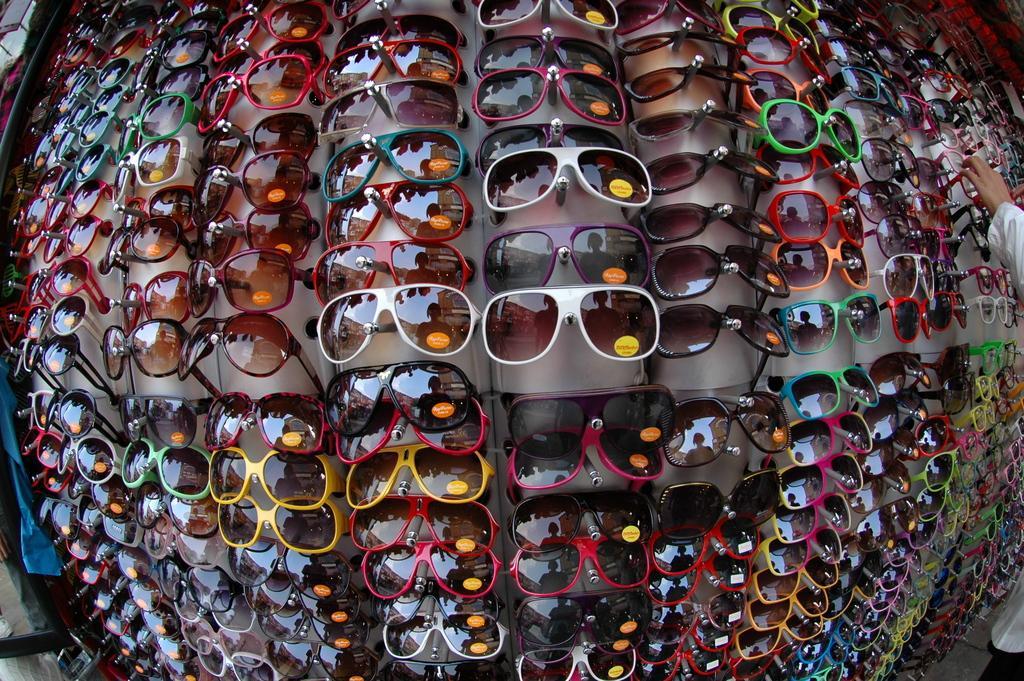Describe this image in one or two sentences. In this picture I can see a bunch of sunglasses to the displaying stand and I can see a human hand picking one of the sunglasses. 